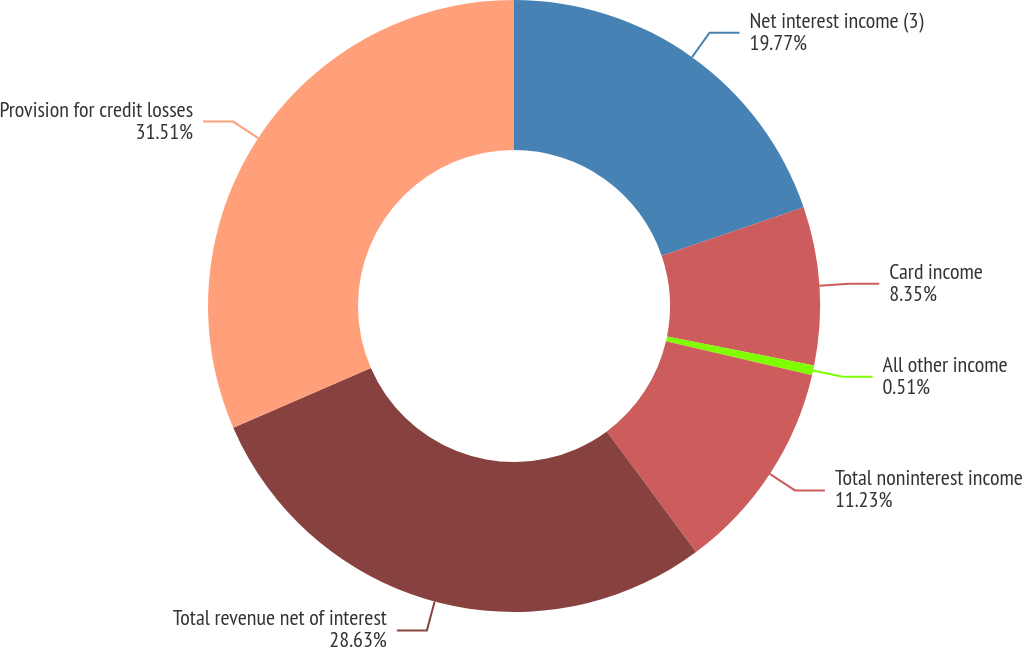Convert chart. <chart><loc_0><loc_0><loc_500><loc_500><pie_chart><fcel>Net interest income (3)<fcel>Card income<fcel>All other income<fcel>Total noninterest income<fcel>Total revenue net of interest<fcel>Provision for credit losses<nl><fcel>19.77%<fcel>8.35%<fcel>0.51%<fcel>11.23%<fcel>28.63%<fcel>31.51%<nl></chart> 